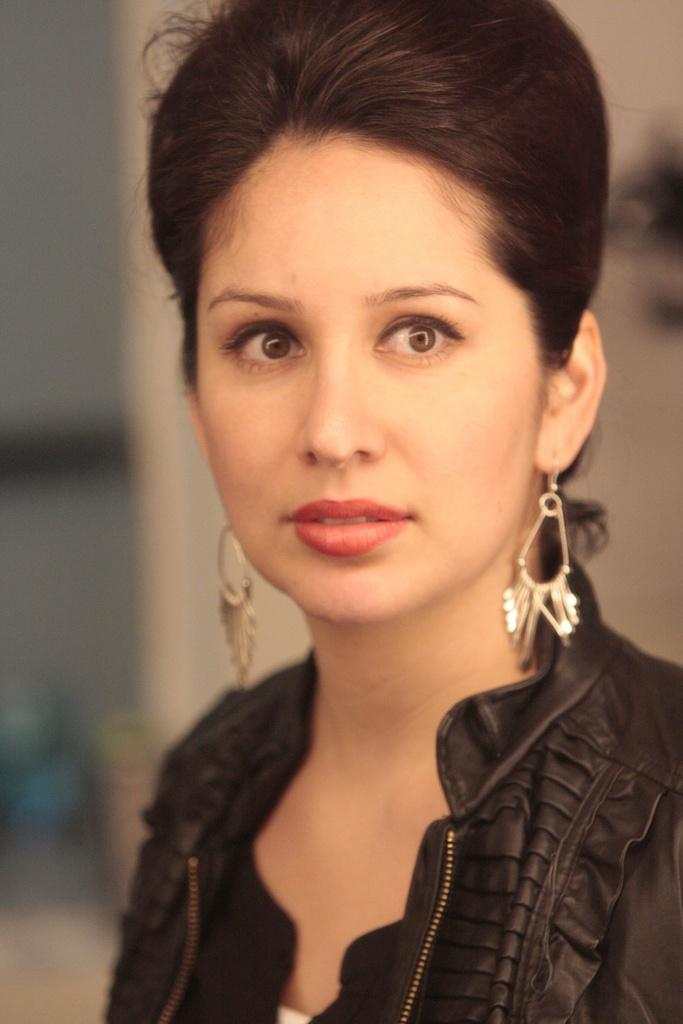Who is the main subject in the image? There is a woman in the image. What is the woman wearing? The woman is wearing a black dress. Can you describe the background of the image? The background of the image is blurred. How many spiders are crawling on the woman's dress in the image? There are no spiders visible on the woman's dress in the image. What type of doll is sitting next to the woman in the image? There is no doll present in the image; it only features a woman wearing a black dress. 